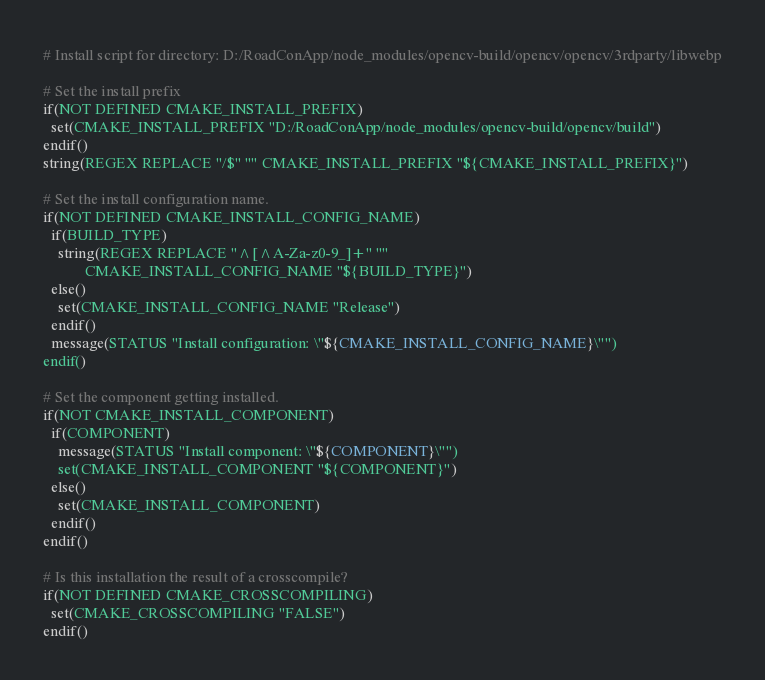<code> <loc_0><loc_0><loc_500><loc_500><_CMake_># Install script for directory: D:/RoadConApp/node_modules/opencv-build/opencv/opencv/3rdparty/libwebp

# Set the install prefix
if(NOT DEFINED CMAKE_INSTALL_PREFIX)
  set(CMAKE_INSTALL_PREFIX "D:/RoadConApp/node_modules/opencv-build/opencv/build")
endif()
string(REGEX REPLACE "/$" "" CMAKE_INSTALL_PREFIX "${CMAKE_INSTALL_PREFIX}")

# Set the install configuration name.
if(NOT DEFINED CMAKE_INSTALL_CONFIG_NAME)
  if(BUILD_TYPE)
    string(REGEX REPLACE "^[^A-Za-z0-9_]+" ""
           CMAKE_INSTALL_CONFIG_NAME "${BUILD_TYPE}")
  else()
    set(CMAKE_INSTALL_CONFIG_NAME "Release")
  endif()
  message(STATUS "Install configuration: \"${CMAKE_INSTALL_CONFIG_NAME}\"")
endif()

# Set the component getting installed.
if(NOT CMAKE_INSTALL_COMPONENT)
  if(COMPONENT)
    message(STATUS "Install component: \"${COMPONENT}\"")
    set(CMAKE_INSTALL_COMPONENT "${COMPONENT}")
  else()
    set(CMAKE_INSTALL_COMPONENT)
  endif()
endif()

# Is this installation the result of a crosscompile?
if(NOT DEFINED CMAKE_CROSSCOMPILING)
  set(CMAKE_CROSSCOMPILING "FALSE")
endif()

</code> 